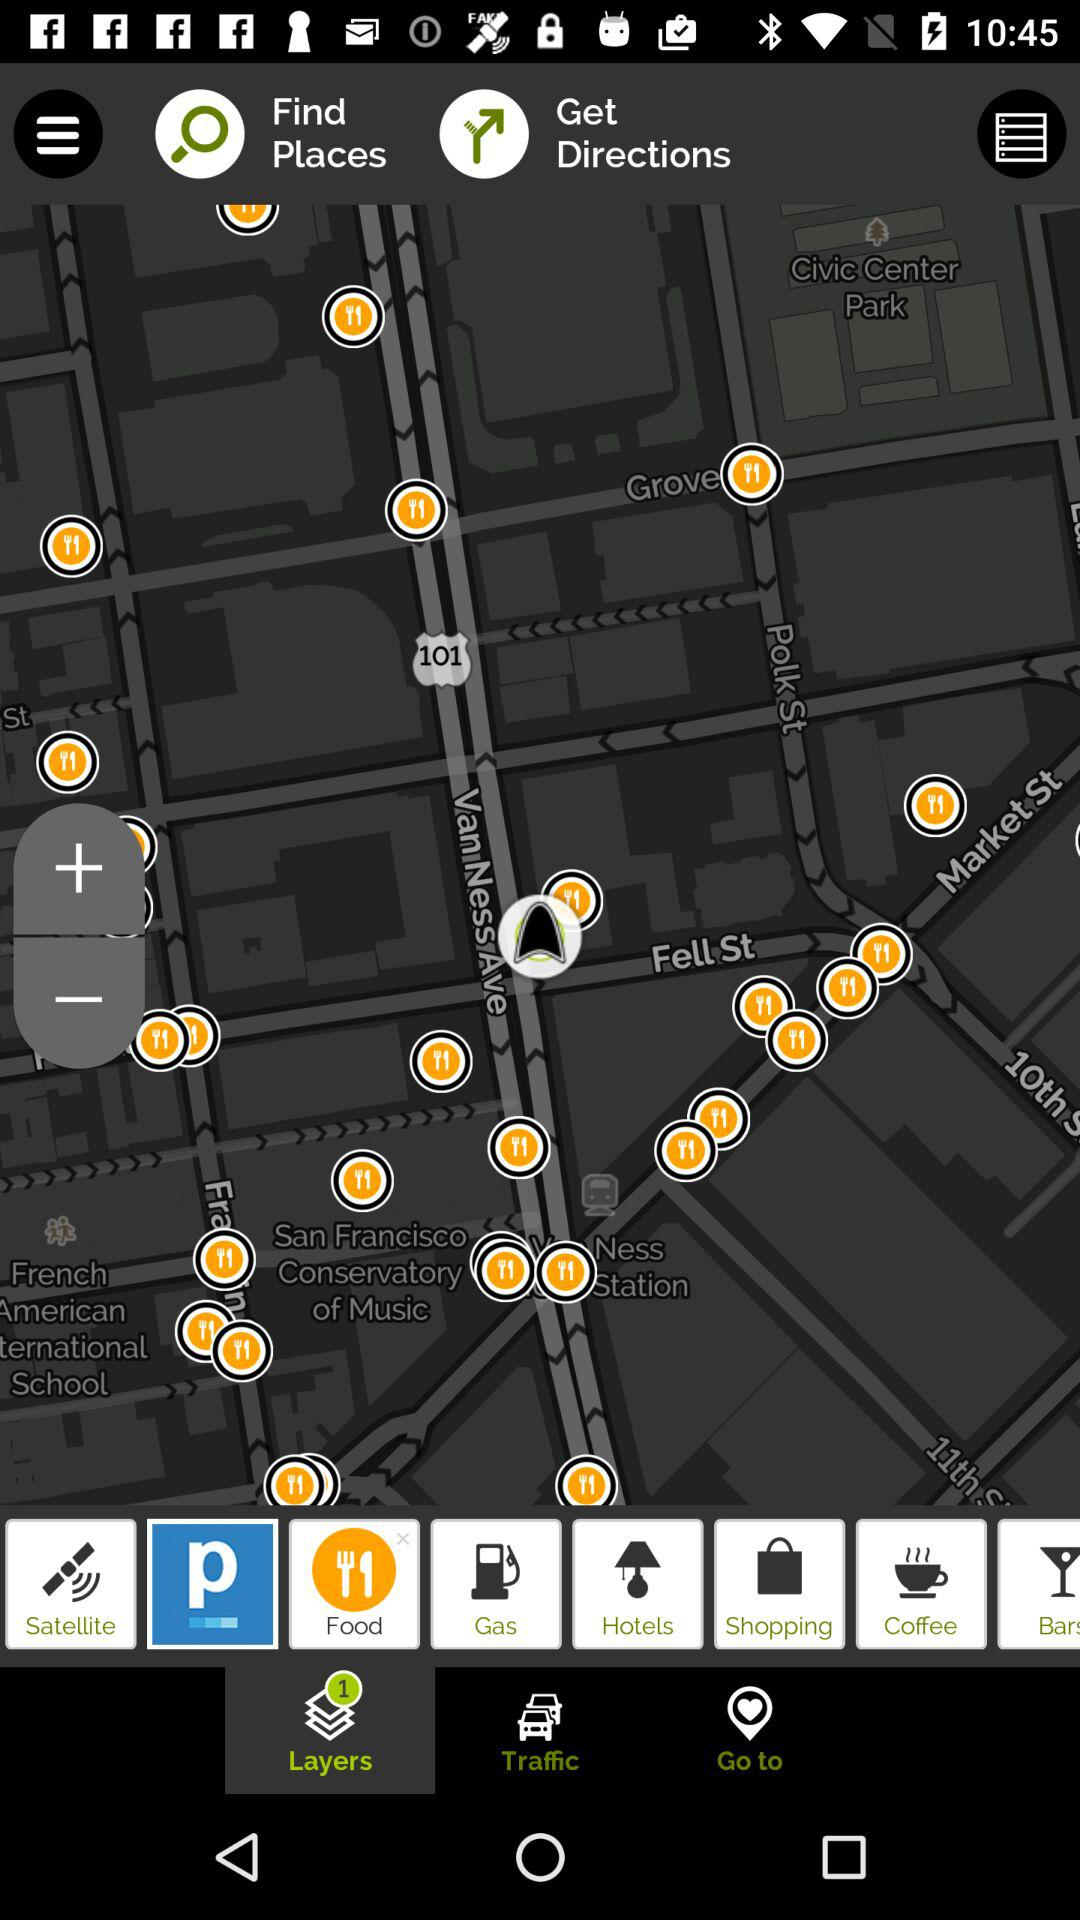How many layers are available in the layers bar?
Answer the question using a single word or phrase. 1 